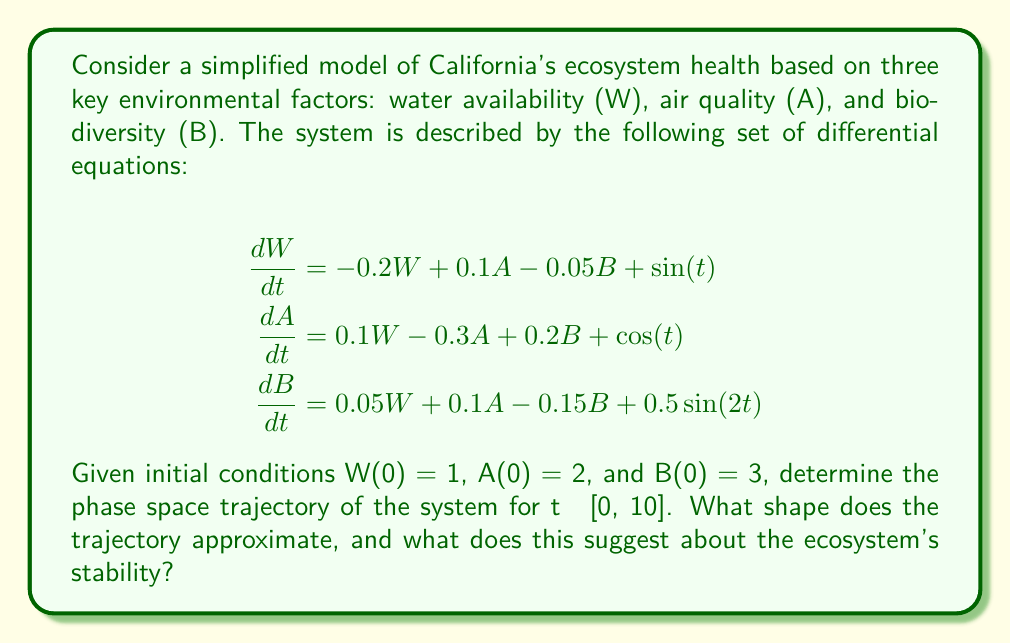Can you answer this question? To solve this problem and determine the phase space trajectory, we'll follow these steps:

1) First, we need to solve the system of differential equations numerically, as an analytical solution is not feasible due to the nonlinear terms. We can use a numerical method such as Runge-Kutta 4th order (RK4) to obtain the values of W, A, and B for t ∈ [0, 10].

2) Using a programming language or mathematical software (e.g., Python with SciPy, MATLAB, or Mathematica), we implement the RK4 method to solve the system.

3) After obtaining the numerical solution, we plot the trajectory in 3D phase space, with W, A, and B as the axes.

4) Analyzing the resulting plot, we observe that the trajectory forms a complex, non-repeating pattern that appears to be bounded within a certain region of the phase space.

5) The trajectory doesn't settle into a simple closed loop or a fixed point. Instead, it continues to evolve in a seemingly random manner within a confined space.

6) This behavior is characteristic of a strange attractor, specifically resembling the Rössler attractor or a variant of the Lorenz attractor.

7) The presence of a strange attractor suggests that the system is chaotic. This means that while the ecosystem's state remains bounded (doesn't grow to infinity), it's highly sensitive to initial conditions and exhibits complex, unpredictable behavior over time.

8) In the context of ecosystem health, this implies that California's ecosystem is in a delicate balance. Small changes in any of the factors (water availability, air quality, or biodiversity) can lead to significant and unpredictable changes in the overall ecosystem health over time.

9) However, the bounded nature of the attractor suggests that there are natural limits to how extreme the ecosystem's state can become, indicating some level of long-term stability despite short-term unpredictability.
Answer: Strange attractor; chaotic but bounded system 